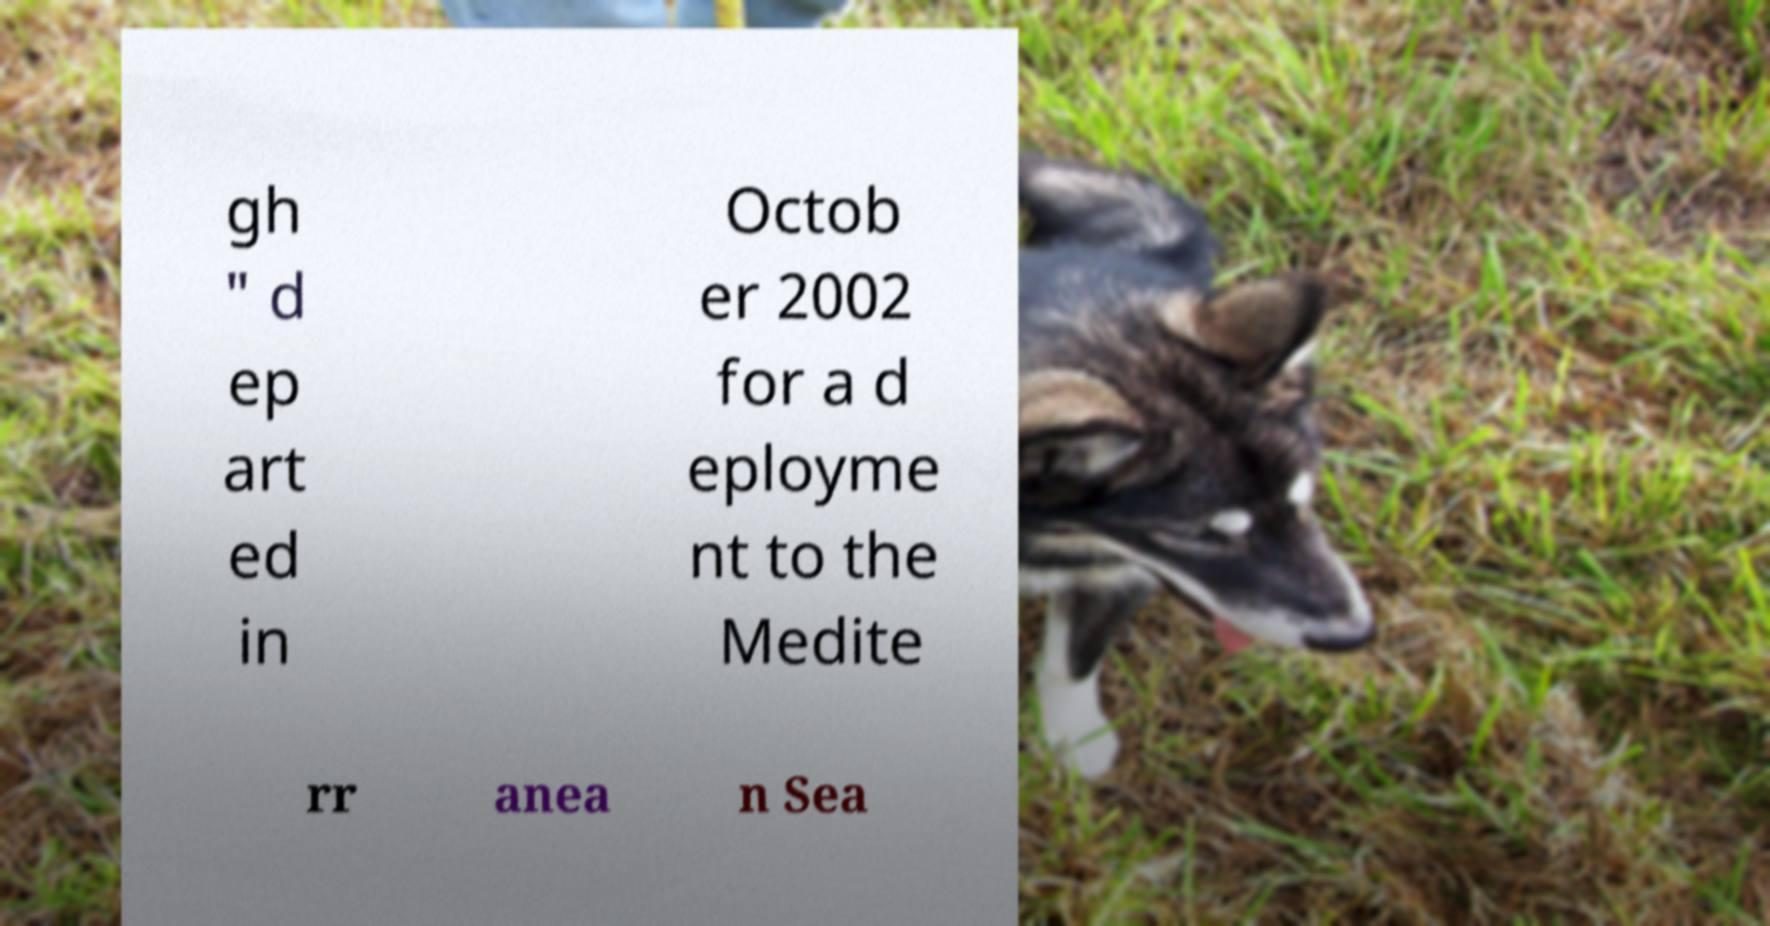What messages or text are displayed in this image? I need them in a readable, typed format. gh " d ep art ed in Octob er 2002 for a d eployme nt to the Medite rr anea n Sea 